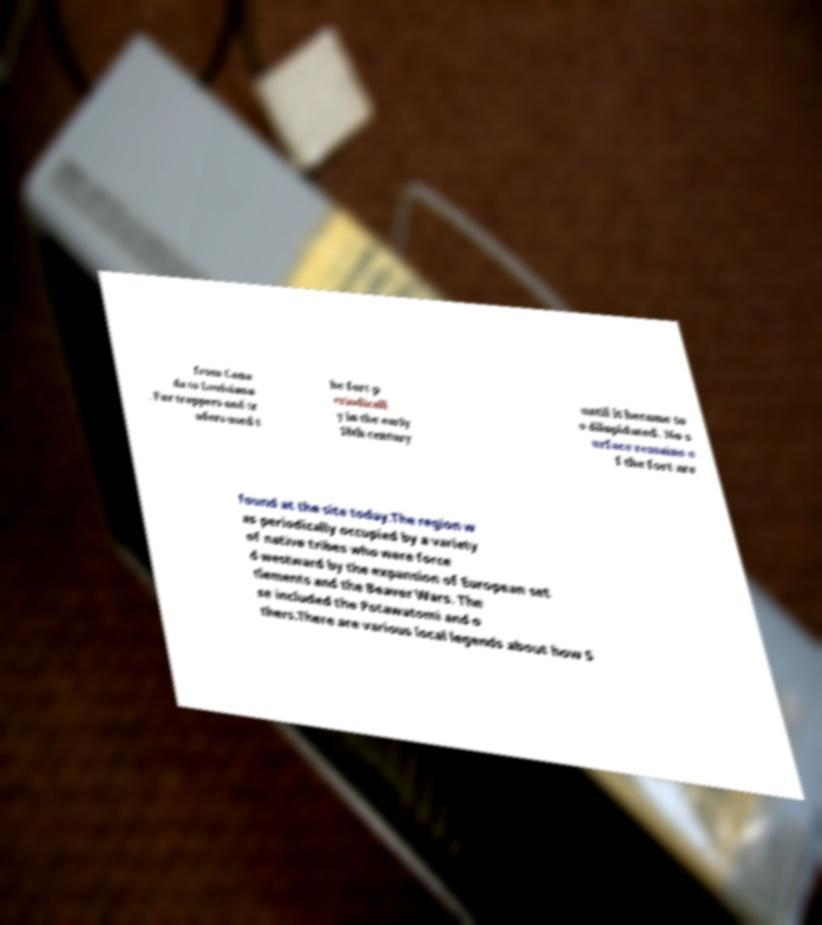Can you accurately transcribe the text from the provided image for me? from Cana da to Louisiana . Fur trappers and tr aders used t he fort p eriodicall y in the early 18th century until it became to o dilapidated. No s urface remains o f the fort are found at the site today.The region w as periodically occupied by a variety of native tribes who were force d westward by the expansion of European set tlements and the Beaver Wars. The se included the Potawatomi and o thers.There are various local legends about how S 